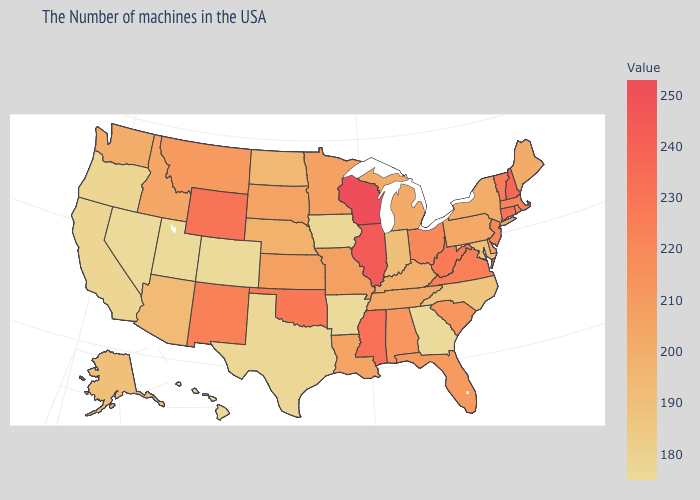Does Kentucky have a higher value than Alaska?
Concise answer only. Yes. Among the states that border Arkansas , which have the lowest value?
Concise answer only. Texas. Does the map have missing data?
Concise answer only. No. Does North Dakota have the highest value in the MidWest?
Keep it brief. No. Does Nevada have the lowest value in the USA?
Keep it brief. Yes. Does Wisconsin have the highest value in the USA?
Answer briefly. Yes. Among the states that border Utah , does New Mexico have the highest value?
Short answer required. No. Among the states that border Ohio , does Kentucky have the lowest value?
Answer briefly. No. 